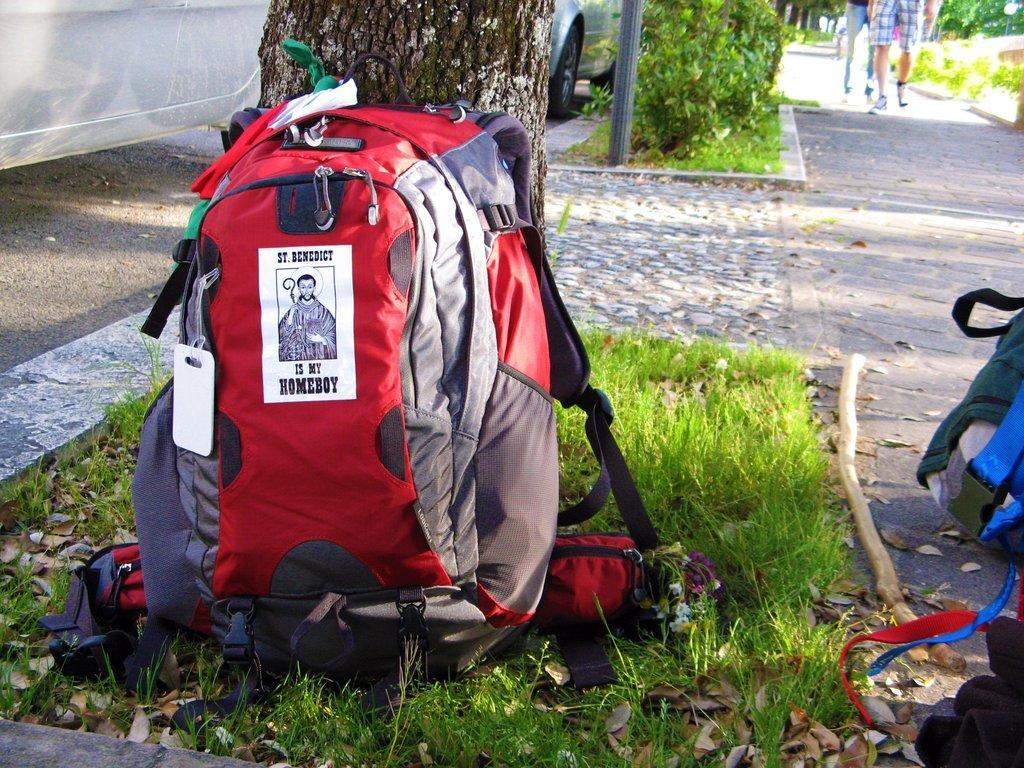Please provide a concise description of this image. In this image i can a bag on the floor there is a grass on the floor,at the back ground i can see a person walking, a tree, a pole,a car. 